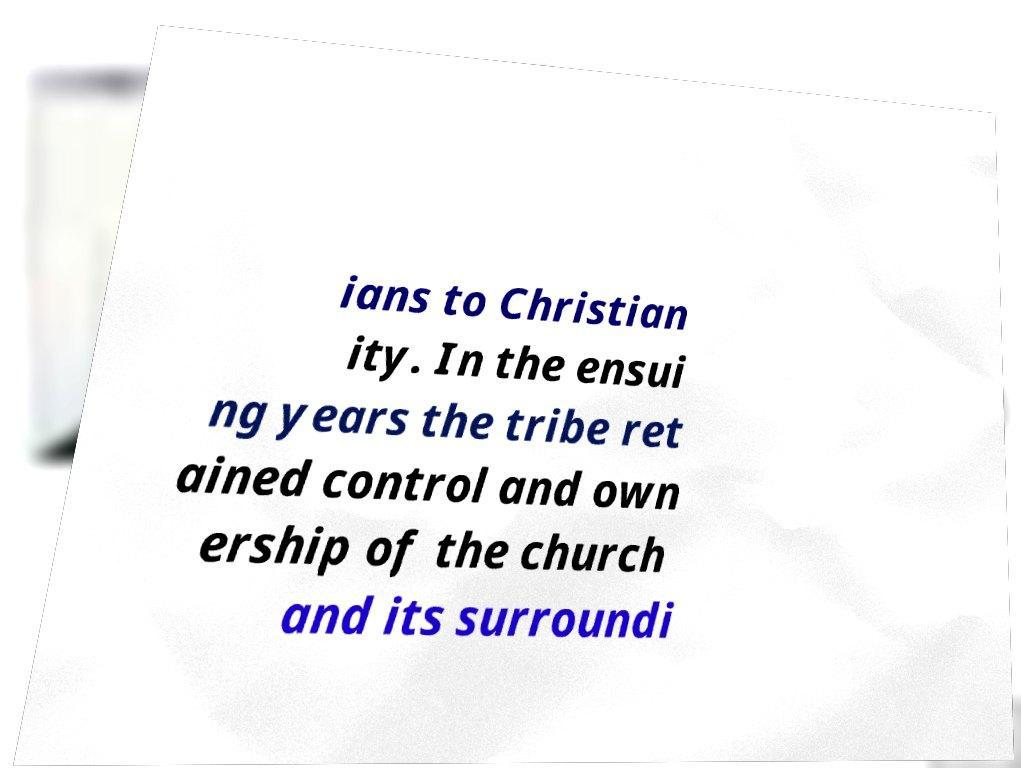I need the written content from this picture converted into text. Can you do that? ians to Christian ity. In the ensui ng years the tribe ret ained control and own ership of the church and its surroundi 